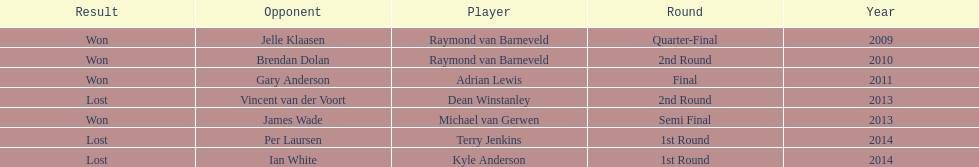How many champions were from norway? 0. 